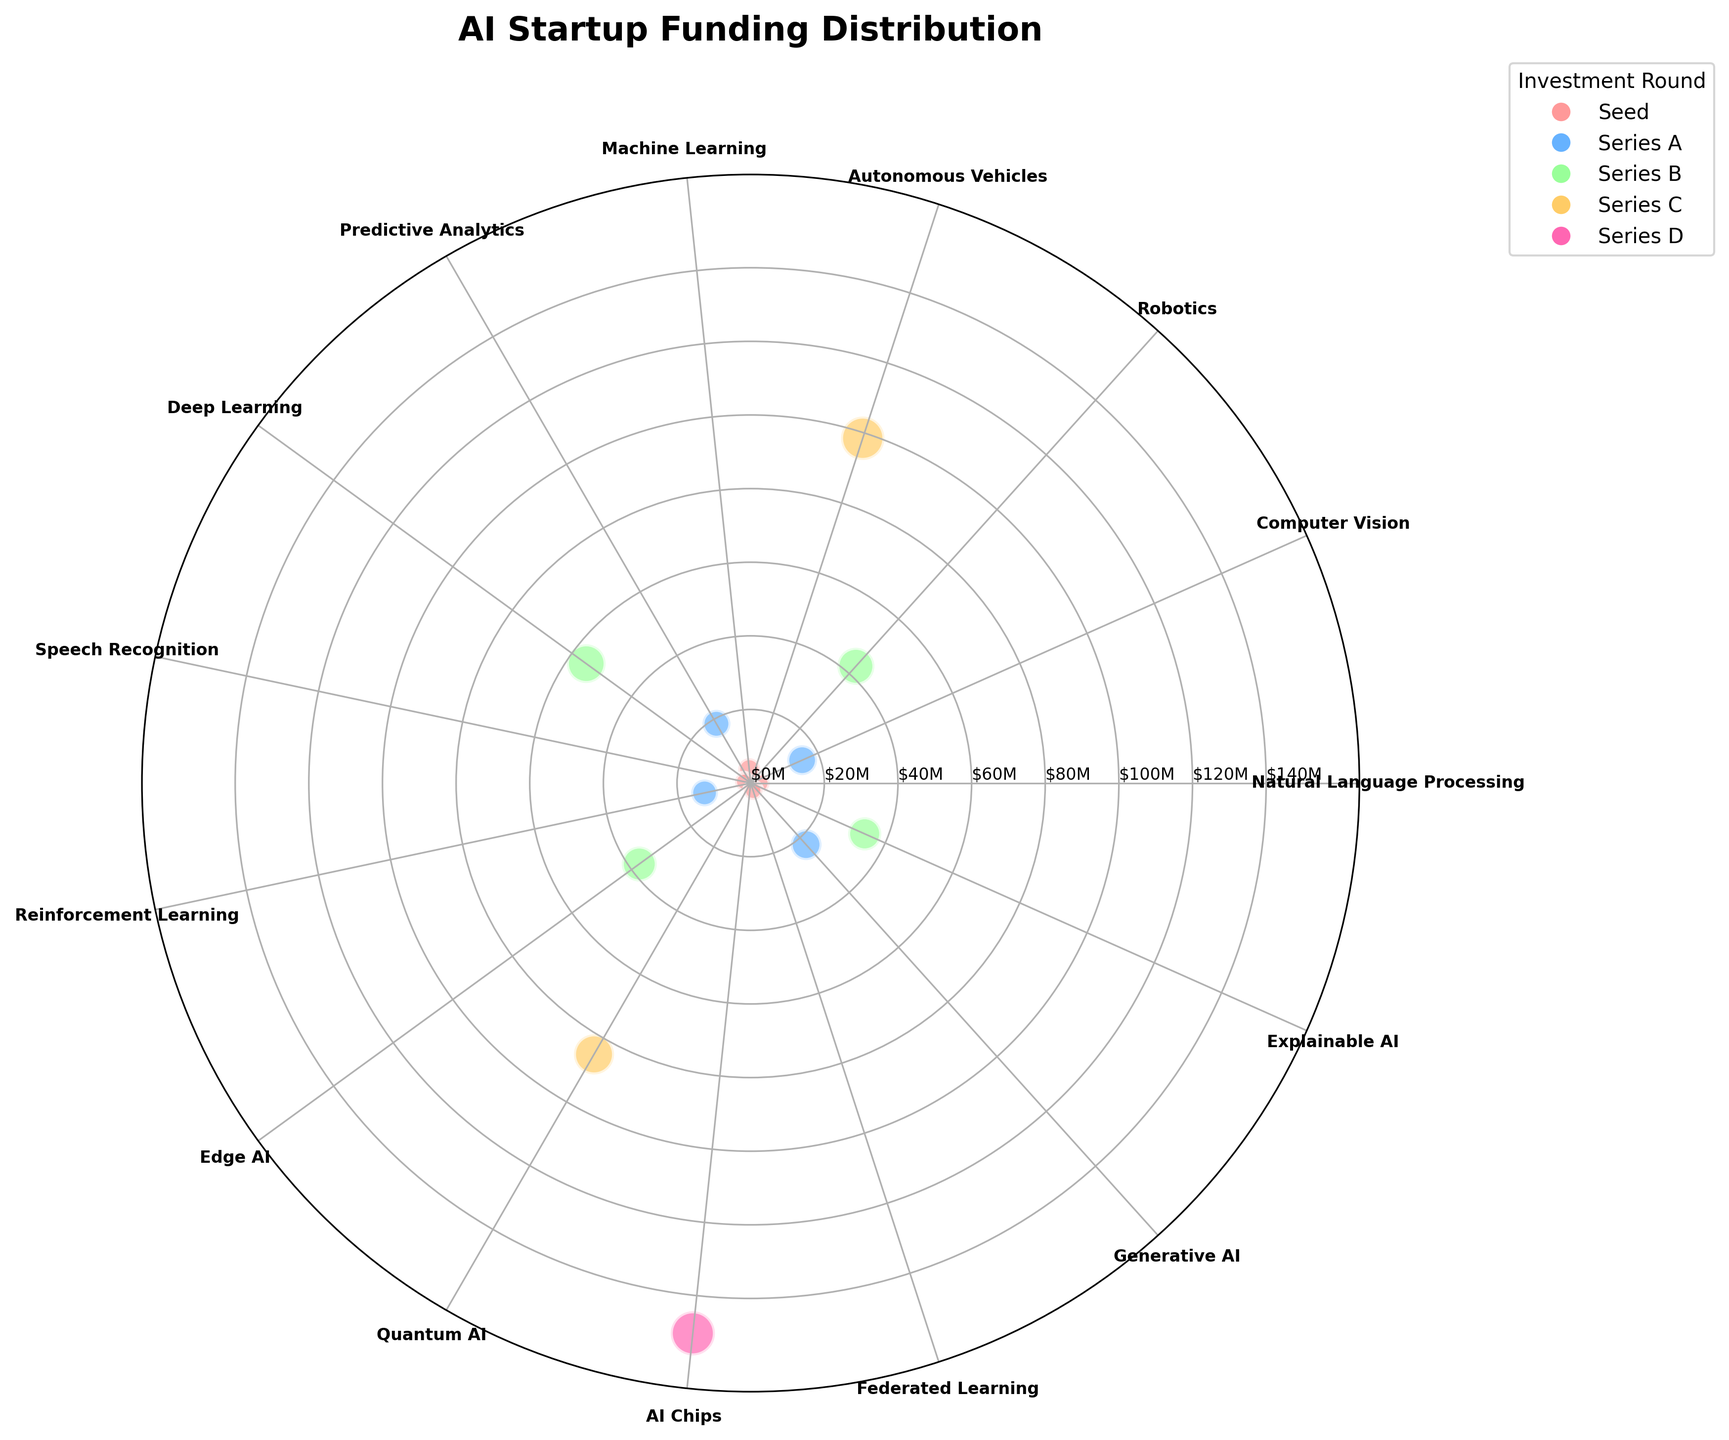What's the title of the chart? The title is typically positioned at the top of the chart. In this case, the title is bold and provided in the code.
Answer: AI Startup Funding Distribution How many technologies are represented in the chart? To determine the number of technologies, count the number of unique data points or labels around the polar plot's circumference.
Answer: 15 Which technology received the highest funding? Identify the data point with the highest radial distance from the center, as the funding amount corresponds to the radial distance.
Answer: AI Chips What is the color used for 'Series A' investment rounds? Check the legend for 'Series A' and note the corresponding color.
Answer: Blue Which two 'Series C' technologies raise the most funding? Look for data points with the 'Series C' color (yellow) and identify the two with the largest radial distances.
Answer: Autonomous Vehicles, Quantum AI What is the total funding amount for 'Seed' investment rounds? Identify all 'Seed' investment rounds from the legend and sum their funding amounts. 2.5 + 3.8 + 1.9 + 2.2
Answer: 10.4 million Which technology holds the largest market share percentage? Identify the data point with the largest bubble size, as the market share corresponds to the bubble size.
Answer: AI Chips Compare the funding amounts of 'Deep Learning' and 'Edge AI' in Series B rounds. Which one is larger? Identify the data points for 'Deep Learning' and 'Edge AI' within Series B and compare their radial distances.
Answer: Deep Learning What's the median funding amount for all represented technologies? List all funding amounts, sort them, and find the middle value. Sorted funding amounts: 1.9, 2.2, 2.5, 3.8, 12.8, 15.3, 18.6, 22.5, 33.9, 37.4, 42.7, 55.2, 85.1, 98.5, 150.3, the middle value is 22.5
Answer: 22.5 million What is the difference in funding between 'Machine Learning' in the Seed round and 'Generative AI' in Series A? Identify the radial distances for both technologies: 'Machine Learning' at 3.8 million and 'Generative AI' at 22.5 million. Subtract 3.8 from 22.5.
Answer: 18.7 million 